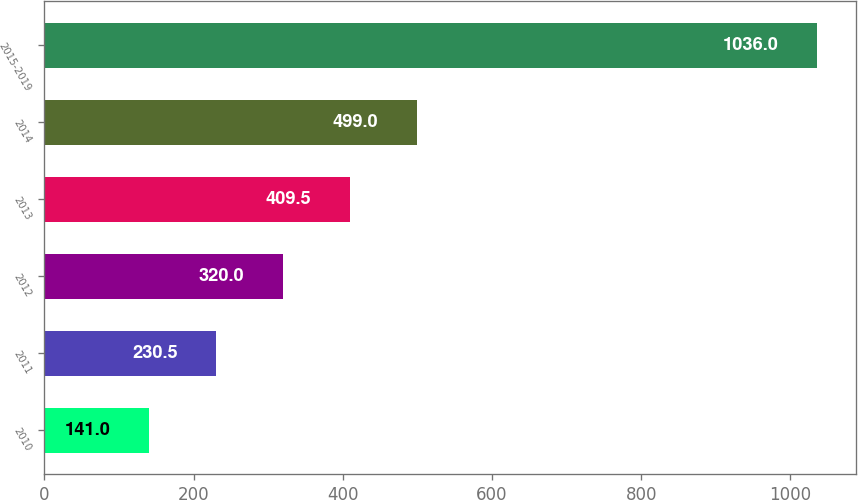Convert chart. <chart><loc_0><loc_0><loc_500><loc_500><bar_chart><fcel>2010<fcel>2011<fcel>2012<fcel>2013<fcel>2014<fcel>2015-2019<nl><fcel>141<fcel>230.5<fcel>320<fcel>409.5<fcel>499<fcel>1036<nl></chart> 